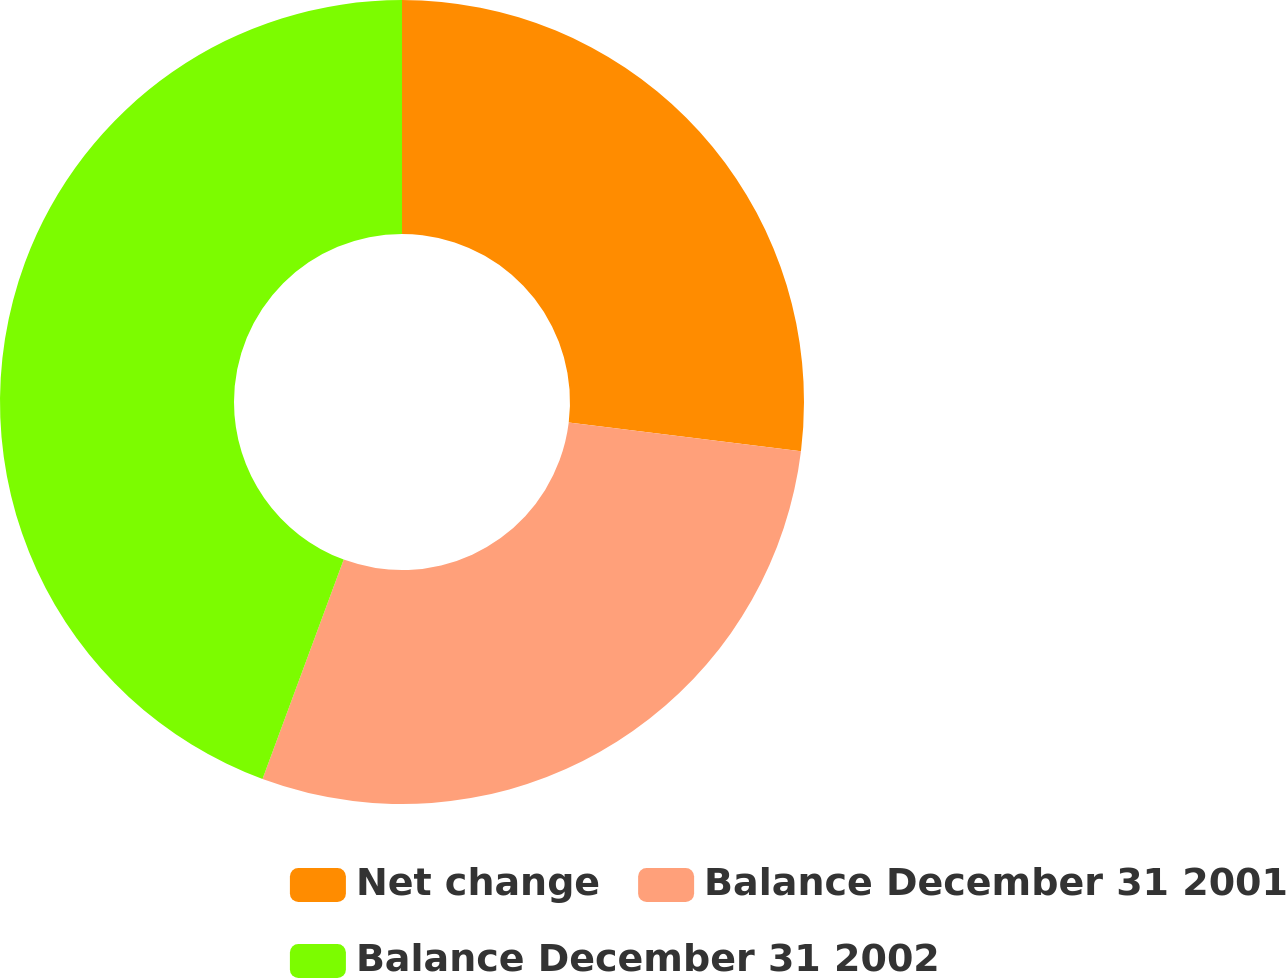<chart> <loc_0><loc_0><loc_500><loc_500><pie_chart><fcel>Net change<fcel>Balance December 31 2001<fcel>Balance December 31 2002<nl><fcel>26.95%<fcel>28.69%<fcel>44.36%<nl></chart> 